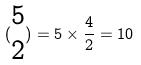Convert formula to latex. <formula><loc_0><loc_0><loc_500><loc_500>( \begin{matrix} 5 \\ 2 \end{matrix} ) = 5 \times \frac { 4 } { 2 } = 1 0</formula> 